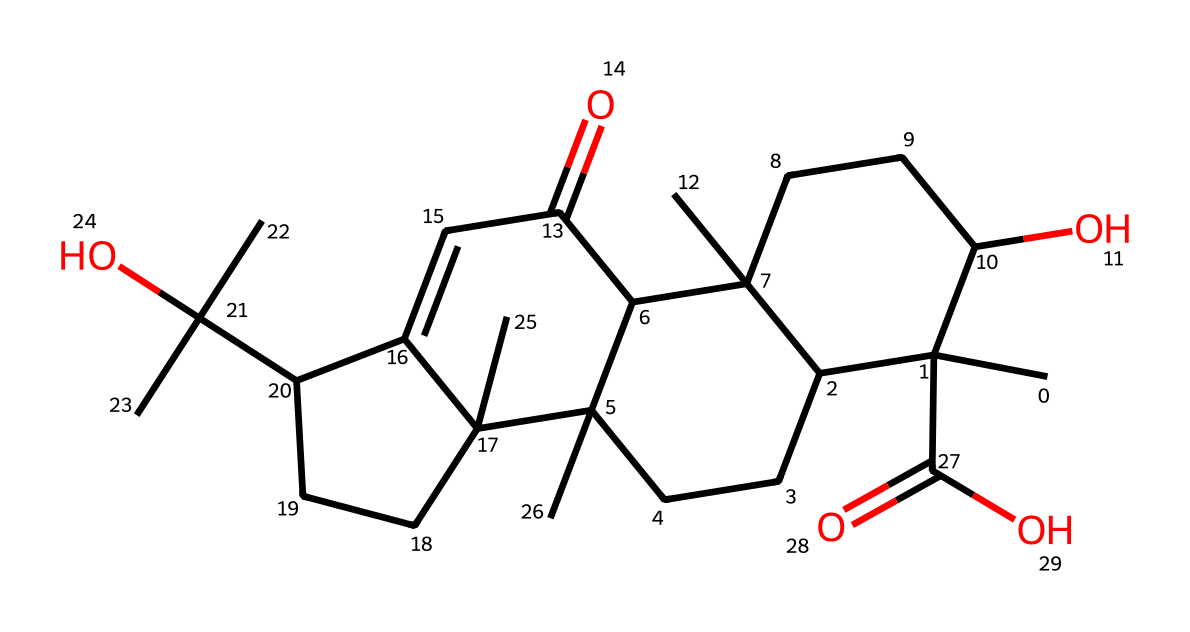What is the molecular formula of frankincense based on the SMILES? To determine the molecular formula, identify the atoms present in the SMILES notation. The structure contains carbon (C), hydrogen (H), and oxygen (O) atoms. Counting gives C15, H26, and O4. Therefore, the molecular formula is C15H26O4.
Answer: C15H26O4 How many oxygen atoms are in the chemical structure? From the SMILES representation, we can identify and count the 'O' symbols that represent oxygen atoms. There are a total of 4 occurrences of 'O.'
Answer: 4 Does frankincense contain any double bonds? In the SMILES notation, double bonds are indicated by the '=' sign. Scanning the representation, you find one instance of '=' which indicates a double bond.
Answer: Yes What type of compound is frankincense classified as based on its structure? The structural elements, namely the presence of multiple carbon chains and rings with oxygen, suggest it belongs to the class of terpenoids or resins. Given its historical and cultural context, frankincense can specifically be classified as a resin.
Answer: resin How many rings are present in the chemical structure? By examining the SMILES string, we can identify the numbers associated with the ring closures (C1, C2, C3, C4). The presence of multiple numbers indicates the formation of rings. After analysis, you conclude that there are 3 interconnected rings.
Answer: 3 What is the primary functional group represented in this structure? Analyzing the chemical structure, particularly looking for common functional groups, you can locate carboxylic acids which are characterized by the presence of -COOH. In the structure, one clear indication of this is the carboxylic acid group (-C(=O)O) found in the compound.
Answer: carboxylic acid Which part of frankincense contributes to its aromatic properties? The aromatic nature arises from specific structural features typical in terpenoids that are present in the structure. In this case, the cyclic and side chain structures, combined with unsaturated bonds, contribute to the overall fragrance, though identifying an exact aromatic ring (like benzene) is not distinctly visible.
Answer: cyclic structures 